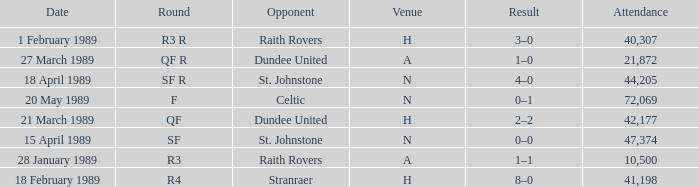On which date does the quarterfinal round happen? 21 March 1989. 